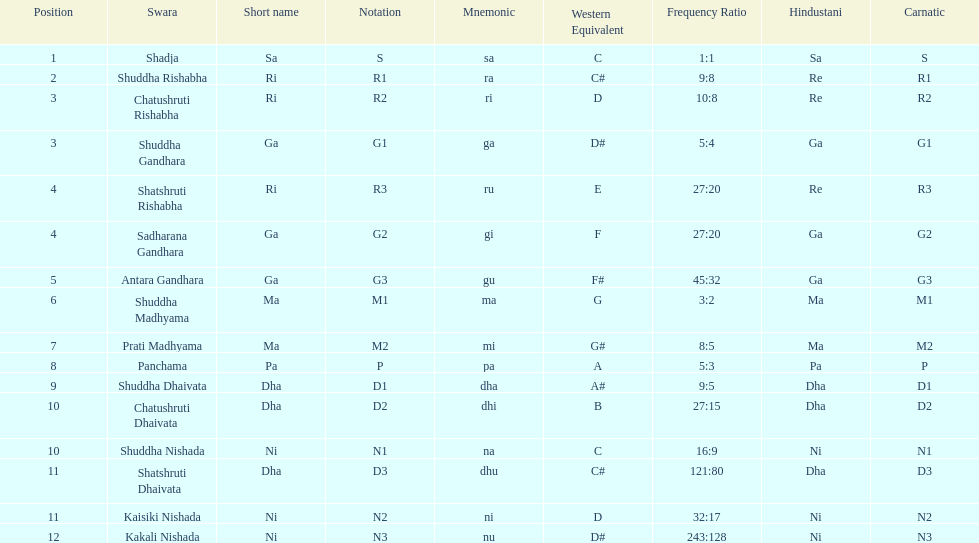Help me parse the entirety of this table. {'header': ['Position', 'Swara', 'Short name', 'Notation', 'Mnemonic', 'Western Equivalent', 'Frequency Ratio', 'Hindustani', 'Carnatic'], 'rows': [['1', 'Shadja', 'Sa', 'S', 'sa', 'C', '1:1', 'Sa', 'S'], ['2', 'Shuddha Rishabha', 'Ri', 'R1', 'ra', 'C#', '9:8', 'Re', 'R1'], ['3', 'Chatushruti Rishabha', 'Ri', 'R2', 'ri', 'D', '10:8', 'Re', 'R2'], ['3', 'Shuddha Gandhara', 'Ga', 'G1', 'ga', 'D#', '5:4', 'Ga', 'G1'], ['4', 'Shatshruti Rishabha', 'Ri', 'R3', 'ru', 'E', '27:20', 'Re', 'R3'], ['4', 'Sadharana Gandhara', 'Ga', 'G2', 'gi', 'F', '27:20', 'Ga', 'G2'], ['5', 'Antara Gandhara', 'Ga', 'G3', 'gu', 'F#', '45:32', 'Ga', 'G3'], ['6', 'Shuddha Madhyama', 'Ma', 'M1', 'ma', 'G', '3:2', 'Ma', 'M1'], ['7', 'Prati Madhyama', 'Ma', 'M2', 'mi', 'G#', '8:5', 'Ma', 'M2'], ['8', 'Panchama', 'Pa', 'P', 'pa', 'A', '5:3', 'Pa', 'P'], ['9', 'Shuddha Dhaivata', 'Dha', 'D1', 'dha', 'A#', '9:5', 'Dha', 'D1'], ['10', 'Chatushruti Dhaivata', 'Dha', 'D2', 'dhi', 'B', '27:15', 'Dha', 'D2'], ['10', 'Shuddha Nishada', 'Ni', 'N1', 'na', 'C', '16:9', 'Ni', 'N1'], ['11', 'Shatshruti Dhaivata', 'Dha', 'D3', 'dhu', 'C#', '121:80', 'Dha', 'D3'], ['11', 'Kaisiki Nishada', 'Ni', 'N2', 'ni', 'D', '32:17', 'Ni', 'N2'], ['12', 'Kakali Nishada', 'Ni', 'N3', 'nu', 'D#', '243:128', 'Ni', 'N3']]} Which swara holds the last position? Kakali Nishada. 